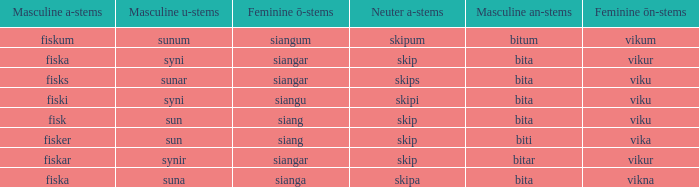What is the u configuration of the expression with a gender-neutral form of skip and a masculine a-termination of fisker? Sun. 